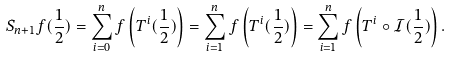Convert formula to latex. <formula><loc_0><loc_0><loc_500><loc_500>S _ { n + 1 } f ( \frac { 1 } { 2 } ) = \sum _ { i = 0 } ^ { n } f \left ( T ^ { i } ( \frac { 1 } { 2 } ) \right ) = \sum _ { i = 1 } ^ { n } f \left ( T ^ { i } ( \frac { 1 } { 2 } ) \right ) = \sum _ { i = 1 } ^ { n } f \left ( T ^ { i } \circ \mathcal { I } ( \frac { 1 } { 2 } ) \right ) .</formula> 